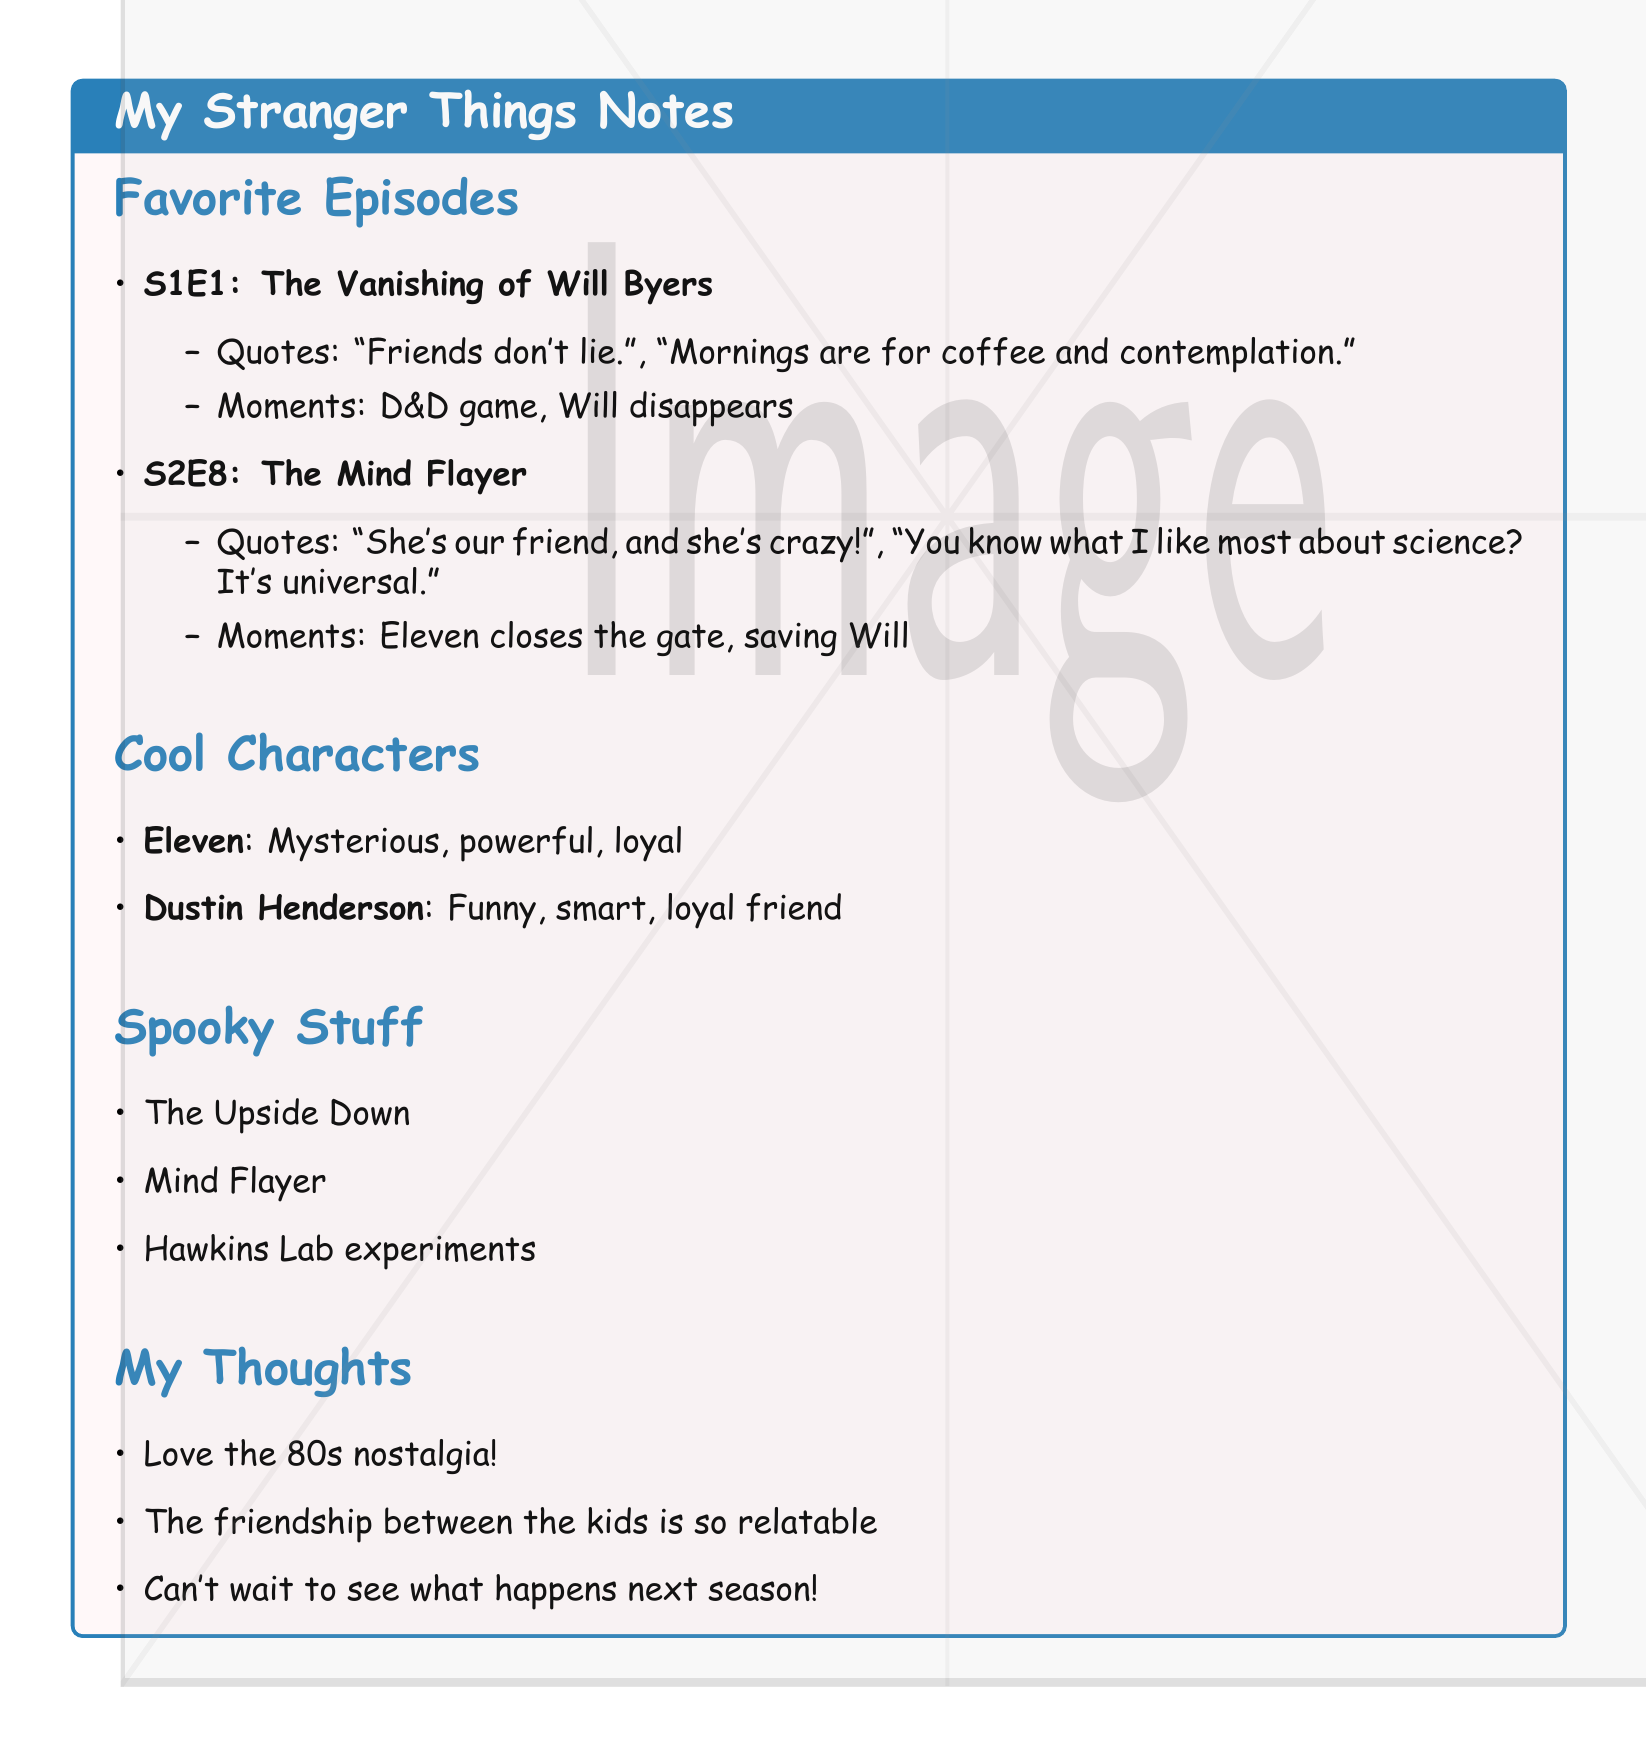What is the title of the first episode? The title of the first episode is "Chapter One: The Vanishing of Will Byers."
Answer: Chapter One: The Vanishing of Will Byers Which character is described as mysterious, powerful, and loyal? The character described with these traits is Eleven.
Answer: Eleven What memorable moment occurs in "Chapter Eight: The Mind Flayer"? A memorable moment in this episode is Eleven closing the gate.
Answer: Eleven closing the gate How many favorite episodes are listed in the notes? There are two favorite episodes listed in the notes.
Answer: 2 What is one quote from "Chapter One: The Vanishing of Will Byers"? One quote from this episode is "Friends don't lie."
Answer: Friends don't lie What personal thought expresses a sentiment about nostalgia? The thought expressing nostalgia is "Love the 80s nostalgia!"
Answer: Love the 80s nostalgia! In "Chapter Eight: The Mind Flayer," what does the group plan to do? The group plans to save Will.
Answer: Save Will Who is described as a funny, smart, loyal friend? The character described this way is Dustin Henderson.
Answer: Dustin Henderson 